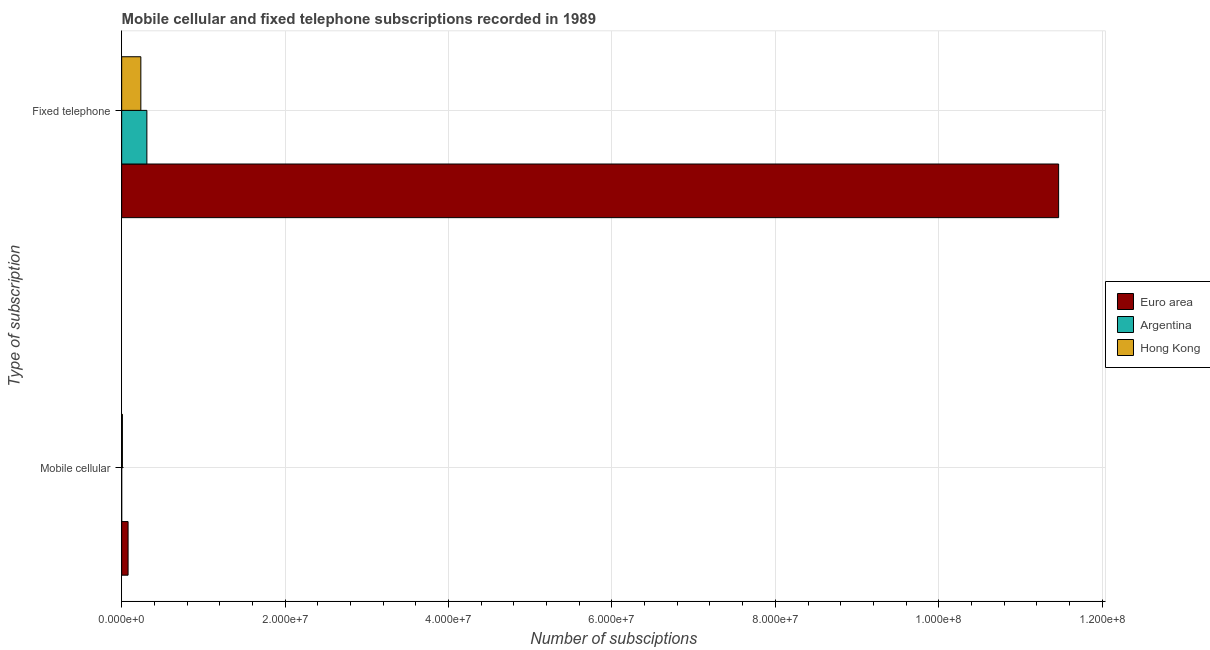Are the number of bars per tick equal to the number of legend labels?
Give a very brief answer. Yes. Are the number of bars on each tick of the Y-axis equal?
Your response must be concise. Yes. What is the label of the 1st group of bars from the top?
Offer a terse response. Fixed telephone. What is the number of fixed telephone subscriptions in Hong Kong?
Offer a very short reply. 2.35e+06. Across all countries, what is the maximum number of mobile cellular subscriptions?
Your answer should be compact. 7.84e+05. Across all countries, what is the minimum number of mobile cellular subscriptions?
Offer a terse response. 2300. In which country was the number of fixed telephone subscriptions minimum?
Give a very brief answer. Hong Kong. What is the total number of fixed telephone subscriptions in the graph?
Your answer should be compact. 1.20e+08. What is the difference between the number of mobile cellular subscriptions in Argentina and that in Hong Kong?
Provide a short and direct response. -8.69e+04. What is the difference between the number of fixed telephone subscriptions in Argentina and the number of mobile cellular subscriptions in Euro area?
Provide a short and direct response. 2.30e+06. What is the average number of fixed telephone subscriptions per country?
Provide a succinct answer. 4.00e+07. What is the difference between the number of fixed telephone subscriptions and number of mobile cellular subscriptions in Hong Kong?
Your answer should be very brief. 2.26e+06. In how many countries, is the number of fixed telephone subscriptions greater than 88000000 ?
Offer a terse response. 1. What is the ratio of the number of mobile cellular subscriptions in Hong Kong to that in Argentina?
Give a very brief answer. 38.78. In how many countries, is the number of mobile cellular subscriptions greater than the average number of mobile cellular subscriptions taken over all countries?
Keep it short and to the point. 1. How many bars are there?
Your answer should be compact. 6. Are all the bars in the graph horizontal?
Your response must be concise. Yes. How many countries are there in the graph?
Your response must be concise. 3. What is the difference between two consecutive major ticks on the X-axis?
Offer a terse response. 2.00e+07. Does the graph contain any zero values?
Keep it short and to the point. No. Where does the legend appear in the graph?
Provide a short and direct response. Center right. How are the legend labels stacked?
Offer a very short reply. Vertical. What is the title of the graph?
Make the answer very short. Mobile cellular and fixed telephone subscriptions recorded in 1989. Does "Tunisia" appear as one of the legend labels in the graph?
Provide a succinct answer. No. What is the label or title of the X-axis?
Give a very brief answer. Number of subsciptions. What is the label or title of the Y-axis?
Your answer should be compact. Type of subscription. What is the Number of subsciptions in Euro area in Mobile cellular?
Provide a short and direct response. 7.84e+05. What is the Number of subsciptions of Argentina in Mobile cellular?
Provide a succinct answer. 2300. What is the Number of subsciptions in Hong Kong in Mobile cellular?
Your answer should be compact. 8.92e+04. What is the Number of subsciptions of Euro area in Fixed telephone?
Make the answer very short. 1.15e+08. What is the Number of subsciptions of Argentina in Fixed telephone?
Your response must be concise. 3.08e+06. What is the Number of subsciptions in Hong Kong in Fixed telephone?
Give a very brief answer. 2.35e+06. Across all Type of subscription, what is the maximum Number of subsciptions in Euro area?
Provide a short and direct response. 1.15e+08. Across all Type of subscription, what is the maximum Number of subsciptions in Argentina?
Your response must be concise. 3.08e+06. Across all Type of subscription, what is the maximum Number of subsciptions in Hong Kong?
Keep it short and to the point. 2.35e+06. Across all Type of subscription, what is the minimum Number of subsciptions in Euro area?
Your answer should be very brief. 7.84e+05. Across all Type of subscription, what is the minimum Number of subsciptions of Argentina?
Your answer should be compact. 2300. Across all Type of subscription, what is the minimum Number of subsciptions in Hong Kong?
Keep it short and to the point. 8.92e+04. What is the total Number of subsciptions of Euro area in the graph?
Offer a very short reply. 1.15e+08. What is the total Number of subsciptions in Argentina in the graph?
Offer a terse response. 3.09e+06. What is the total Number of subsciptions in Hong Kong in the graph?
Provide a short and direct response. 2.43e+06. What is the difference between the Number of subsciptions in Euro area in Mobile cellular and that in Fixed telephone?
Give a very brief answer. -1.14e+08. What is the difference between the Number of subsciptions of Argentina in Mobile cellular and that in Fixed telephone?
Ensure brevity in your answer.  -3.08e+06. What is the difference between the Number of subsciptions in Hong Kong in Mobile cellular and that in Fixed telephone?
Ensure brevity in your answer.  -2.26e+06. What is the difference between the Number of subsciptions of Euro area in Mobile cellular and the Number of subsciptions of Argentina in Fixed telephone?
Your response must be concise. -2.30e+06. What is the difference between the Number of subsciptions in Euro area in Mobile cellular and the Number of subsciptions in Hong Kong in Fixed telephone?
Give a very brief answer. -1.56e+06. What is the difference between the Number of subsciptions of Argentina in Mobile cellular and the Number of subsciptions of Hong Kong in Fixed telephone?
Give a very brief answer. -2.34e+06. What is the average Number of subsciptions of Euro area per Type of subscription?
Make the answer very short. 5.77e+07. What is the average Number of subsciptions of Argentina per Type of subscription?
Provide a succinct answer. 1.54e+06. What is the average Number of subsciptions of Hong Kong per Type of subscription?
Your response must be concise. 1.22e+06. What is the difference between the Number of subsciptions of Euro area and Number of subsciptions of Argentina in Mobile cellular?
Provide a short and direct response. 7.81e+05. What is the difference between the Number of subsciptions in Euro area and Number of subsciptions in Hong Kong in Mobile cellular?
Your answer should be compact. 6.95e+05. What is the difference between the Number of subsciptions in Argentina and Number of subsciptions in Hong Kong in Mobile cellular?
Provide a succinct answer. -8.69e+04. What is the difference between the Number of subsciptions in Euro area and Number of subsciptions in Argentina in Fixed telephone?
Offer a terse response. 1.12e+08. What is the difference between the Number of subsciptions in Euro area and Number of subsciptions in Hong Kong in Fixed telephone?
Make the answer very short. 1.12e+08. What is the difference between the Number of subsciptions in Argentina and Number of subsciptions in Hong Kong in Fixed telephone?
Keep it short and to the point. 7.39e+05. What is the ratio of the Number of subsciptions in Euro area in Mobile cellular to that in Fixed telephone?
Your response must be concise. 0.01. What is the ratio of the Number of subsciptions of Argentina in Mobile cellular to that in Fixed telephone?
Provide a succinct answer. 0. What is the ratio of the Number of subsciptions of Hong Kong in Mobile cellular to that in Fixed telephone?
Ensure brevity in your answer.  0.04. What is the difference between the highest and the second highest Number of subsciptions of Euro area?
Offer a terse response. 1.14e+08. What is the difference between the highest and the second highest Number of subsciptions of Argentina?
Offer a terse response. 3.08e+06. What is the difference between the highest and the second highest Number of subsciptions in Hong Kong?
Provide a short and direct response. 2.26e+06. What is the difference between the highest and the lowest Number of subsciptions of Euro area?
Keep it short and to the point. 1.14e+08. What is the difference between the highest and the lowest Number of subsciptions in Argentina?
Offer a very short reply. 3.08e+06. What is the difference between the highest and the lowest Number of subsciptions in Hong Kong?
Your response must be concise. 2.26e+06. 